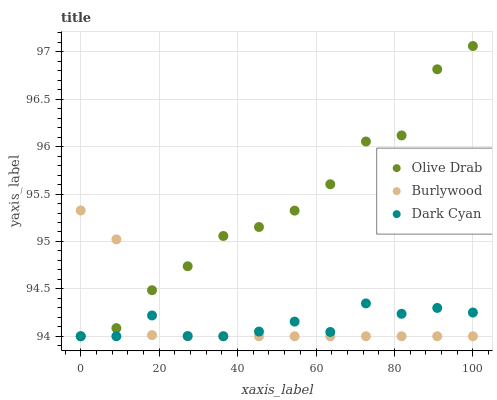Does Dark Cyan have the minimum area under the curve?
Answer yes or no. Yes. Does Olive Drab have the maximum area under the curve?
Answer yes or no. Yes. Does Olive Drab have the minimum area under the curve?
Answer yes or no. No. Does Dark Cyan have the maximum area under the curve?
Answer yes or no. No. Is Burlywood the smoothest?
Answer yes or no. Yes. Is Olive Drab the roughest?
Answer yes or no. Yes. Is Dark Cyan the smoothest?
Answer yes or no. No. Is Dark Cyan the roughest?
Answer yes or no. No. Does Burlywood have the lowest value?
Answer yes or no. Yes. Does Olive Drab have the highest value?
Answer yes or no. Yes. Does Dark Cyan have the highest value?
Answer yes or no. No. Does Burlywood intersect Olive Drab?
Answer yes or no. Yes. Is Burlywood less than Olive Drab?
Answer yes or no. No. Is Burlywood greater than Olive Drab?
Answer yes or no. No. 